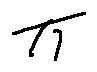Convert formula to latex. <formula><loc_0><loc_0><loc_500><loc_500>\pi</formula> 